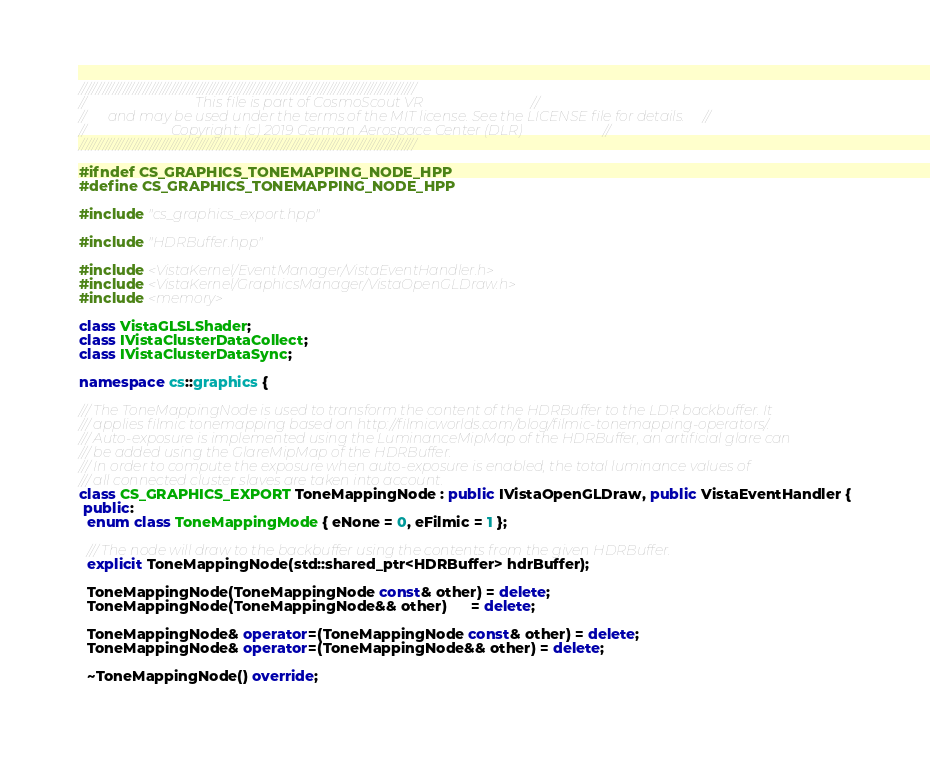<code> <loc_0><loc_0><loc_500><loc_500><_C++_>////////////////////////////////////////////////////////////////////////////////////////////////////
//                               This file is part of CosmoScout VR                               //
//      and may be used under the terms of the MIT license. See the LICENSE file for details.     //
//                        Copyright: (c) 2019 German Aerospace Center (DLR)                       //
////////////////////////////////////////////////////////////////////////////////////////////////////

#ifndef CS_GRAPHICS_TONEMAPPING_NODE_HPP
#define CS_GRAPHICS_TONEMAPPING_NODE_HPP

#include "cs_graphics_export.hpp"

#include "HDRBuffer.hpp"

#include <VistaKernel/EventManager/VistaEventHandler.h>
#include <VistaKernel/GraphicsManager/VistaOpenGLDraw.h>
#include <memory>

class VistaGLSLShader;
class IVistaClusterDataCollect;
class IVistaClusterDataSync;

namespace cs::graphics {

/// The ToneMappingNode is used to transform the content of the HDRBuffer to the LDR backbuffer. It
/// applies filmic tonemapping based on http://filmicworlds.com/blog/filmic-tonemapping-operators/.
/// Auto-exposure is implemented using the LuminanceMipMap of the HDRBuffer, an artificial glare can
/// be added using the GlareMipMap of the HDRBuffer.
/// In order to compute the exposure when auto-exposure is enabled, the total luminance values of
/// all connected cluster slaves are taken into account.
class CS_GRAPHICS_EXPORT ToneMappingNode : public IVistaOpenGLDraw, public VistaEventHandler {
 public:
  enum class ToneMappingMode { eNone = 0, eFilmic = 1 };

  /// The node will draw to the backbuffer using the contents from the given HDRBuffer.
  explicit ToneMappingNode(std::shared_ptr<HDRBuffer> hdrBuffer);

  ToneMappingNode(ToneMappingNode const& other) = delete;
  ToneMappingNode(ToneMappingNode&& other)      = delete;

  ToneMappingNode& operator=(ToneMappingNode const& other) = delete;
  ToneMappingNode& operator=(ToneMappingNode&& other) = delete;

  ~ToneMappingNode() override;
</code> 